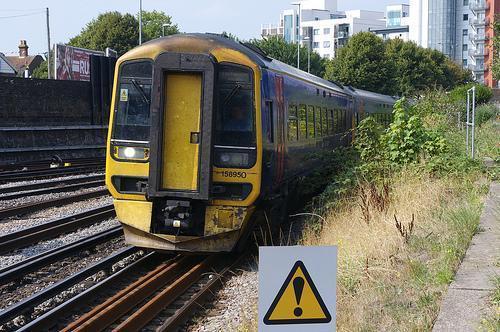How many poles are visible in this picture?
Give a very brief answer. 8. 